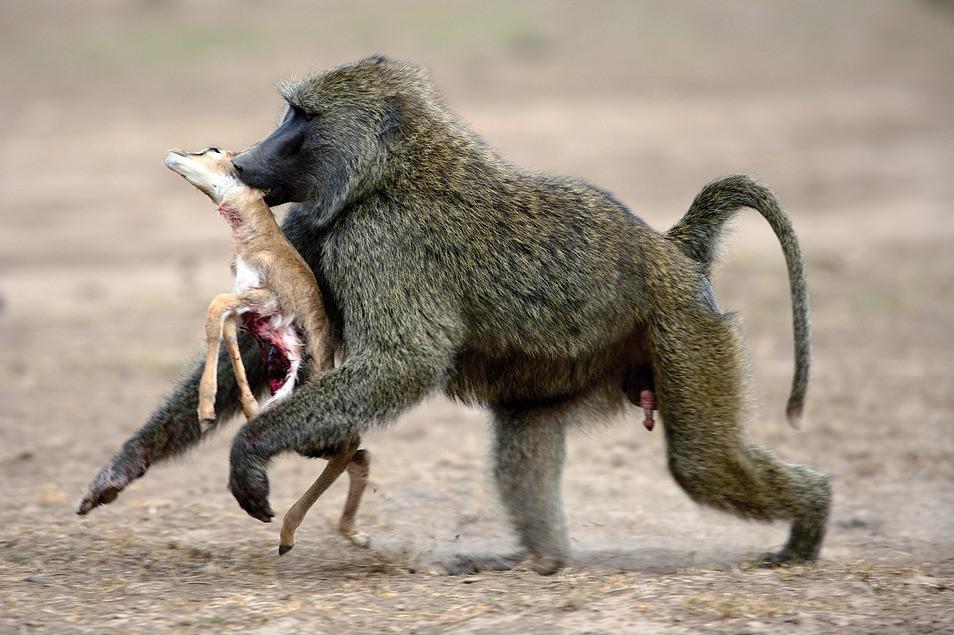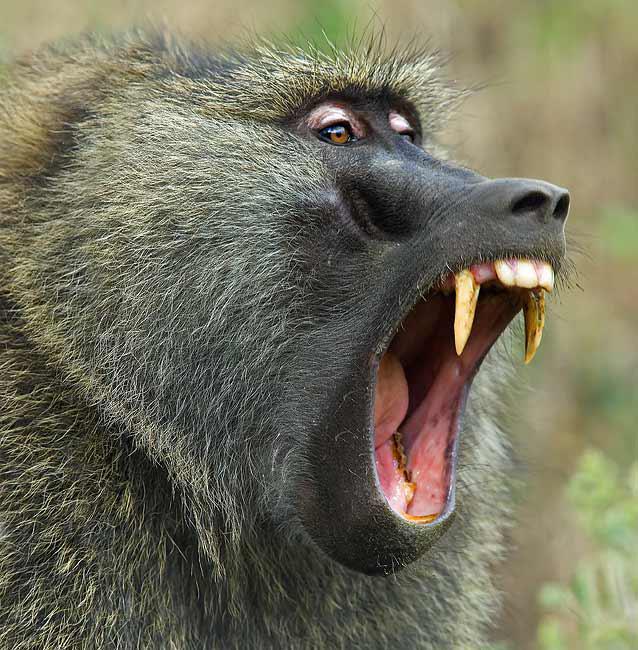The first image is the image on the left, the second image is the image on the right. Evaluate the accuracy of this statement regarding the images: "There's at least one monkey eating an animal.". Is it true? Answer yes or no. Yes. 